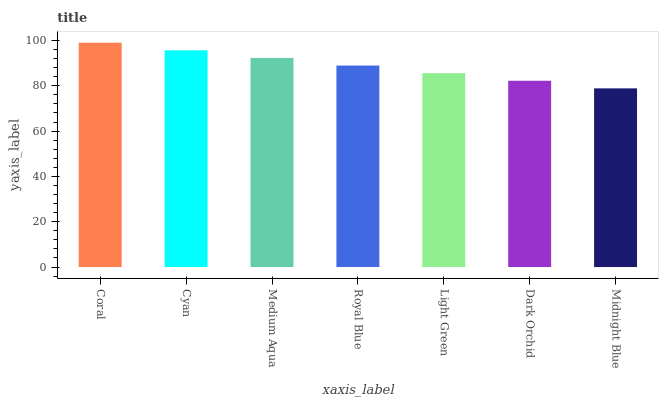Is Midnight Blue the minimum?
Answer yes or no. Yes. Is Coral the maximum?
Answer yes or no. Yes. Is Cyan the minimum?
Answer yes or no. No. Is Cyan the maximum?
Answer yes or no. No. Is Coral greater than Cyan?
Answer yes or no. Yes. Is Cyan less than Coral?
Answer yes or no. Yes. Is Cyan greater than Coral?
Answer yes or no. No. Is Coral less than Cyan?
Answer yes or no. No. Is Royal Blue the high median?
Answer yes or no. Yes. Is Royal Blue the low median?
Answer yes or no. Yes. Is Medium Aqua the high median?
Answer yes or no. No. Is Midnight Blue the low median?
Answer yes or no. No. 